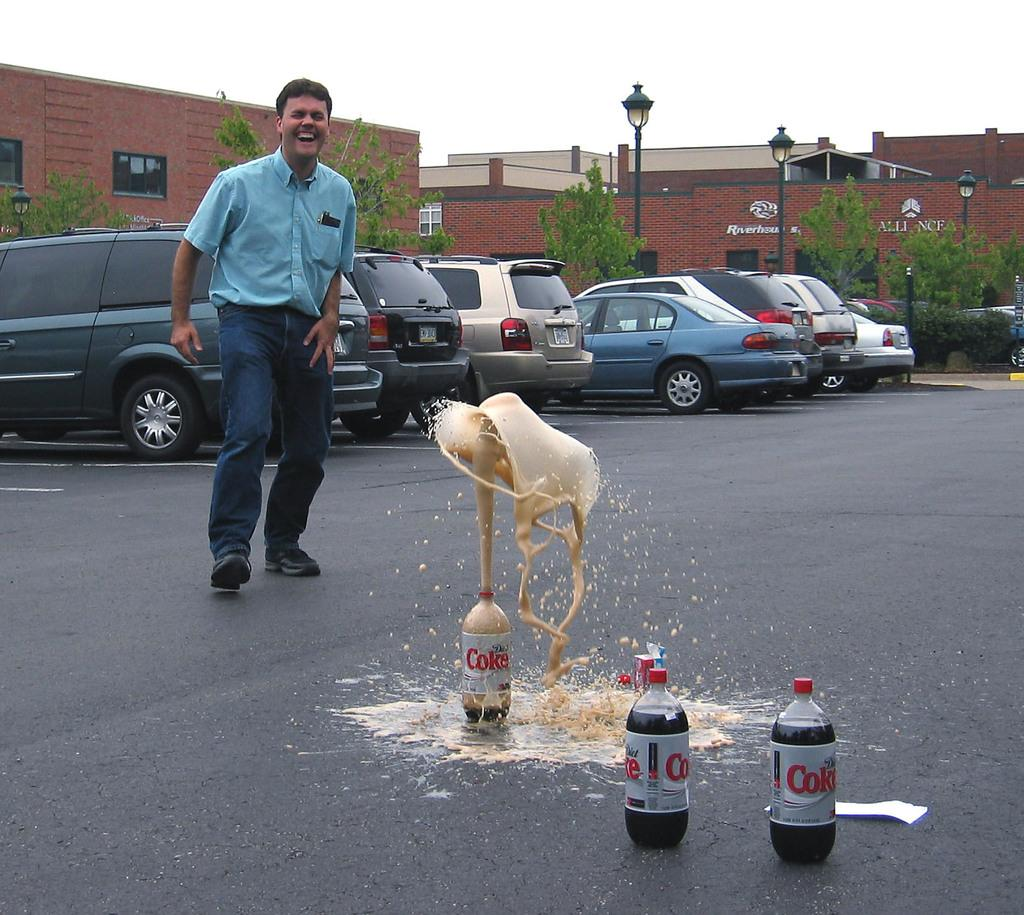What is the man in the image doing? The man is standing and laughing in the image. Where is the man located in the image? The man is on the road in the image. What is in front of the man? There are three bottles in front of the man. What can be seen in the background of the image? There are cars, a plant, a light pole, and the sky visible in the background of the image. What type of cup is the man holding in the image? There is no cup present in the image; the man is not holding anything. 